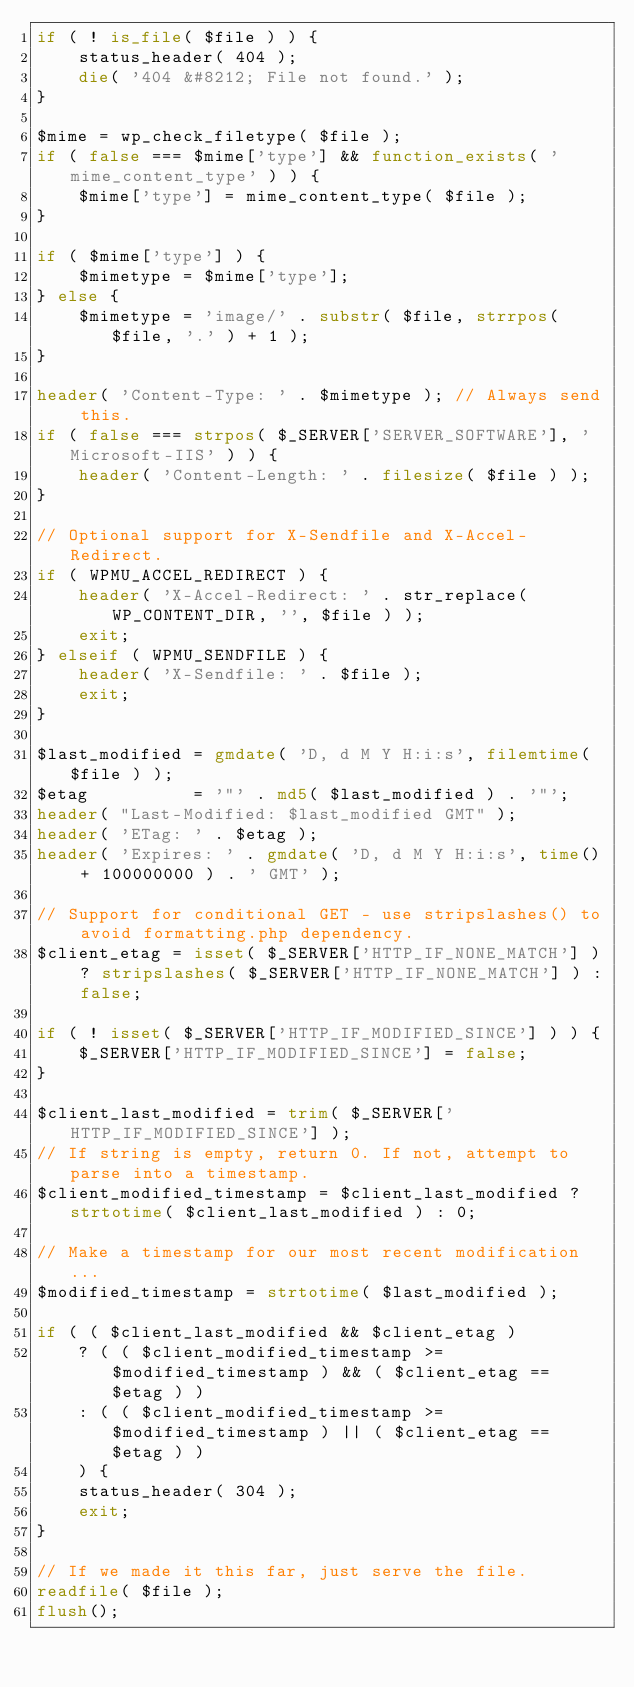<code> <loc_0><loc_0><loc_500><loc_500><_PHP_>if ( ! is_file( $file ) ) {
	status_header( 404 );
	die( '404 &#8212; File not found.' );
}

$mime = wp_check_filetype( $file );
if ( false === $mime['type'] && function_exists( 'mime_content_type' ) ) {
	$mime['type'] = mime_content_type( $file );
}

if ( $mime['type'] ) {
	$mimetype = $mime['type'];
} else {
	$mimetype = 'image/' . substr( $file, strrpos( $file, '.' ) + 1 );
}

header( 'Content-Type: ' . $mimetype ); // Always send this.
if ( false === strpos( $_SERVER['SERVER_SOFTWARE'], 'Microsoft-IIS' ) ) {
	header( 'Content-Length: ' . filesize( $file ) );
}

// Optional support for X-Sendfile and X-Accel-Redirect.
if ( WPMU_ACCEL_REDIRECT ) {
	header( 'X-Accel-Redirect: ' . str_replace( WP_CONTENT_DIR, '', $file ) );
	exit;
} elseif ( WPMU_SENDFILE ) {
	header( 'X-Sendfile: ' . $file );
	exit;
}

$last_modified = gmdate( 'D, d M Y H:i:s', filemtime( $file ) );
$etag          = '"' . md5( $last_modified ) . '"';
header( "Last-Modified: $last_modified GMT" );
header( 'ETag: ' . $etag );
header( 'Expires: ' . gmdate( 'D, d M Y H:i:s', time() + 100000000 ) . ' GMT' );

// Support for conditional GET - use stripslashes() to avoid formatting.php dependency.
$client_etag = isset( $_SERVER['HTTP_IF_NONE_MATCH'] ) ? stripslashes( $_SERVER['HTTP_IF_NONE_MATCH'] ) : false;

if ( ! isset( $_SERVER['HTTP_IF_MODIFIED_SINCE'] ) ) {
	$_SERVER['HTTP_IF_MODIFIED_SINCE'] = false;
}

$client_last_modified = trim( $_SERVER['HTTP_IF_MODIFIED_SINCE'] );
// If string is empty, return 0. If not, attempt to parse into a timestamp.
$client_modified_timestamp = $client_last_modified ? strtotime( $client_last_modified ) : 0;

// Make a timestamp for our most recent modification...
$modified_timestamp = strtotime( $last_modified );

if ( ( $client_last_modified && $client_etag )
	? ( ( $client_modified_timestamp >= $modified_timestamp ) && ( $client_etag == $etag ) )
	: ( ( $client_modified_timestamp >= $modified_timestamp ) || ( $client_etag == $etag ) )
	) {
	status_header( 304 );
	exit;
}

// If we made it this far, just serve the file.
readfile( $file );
flush();
</code> 